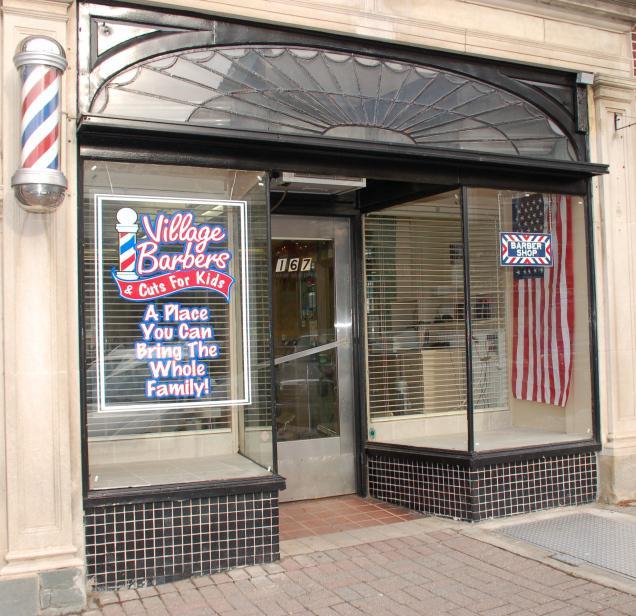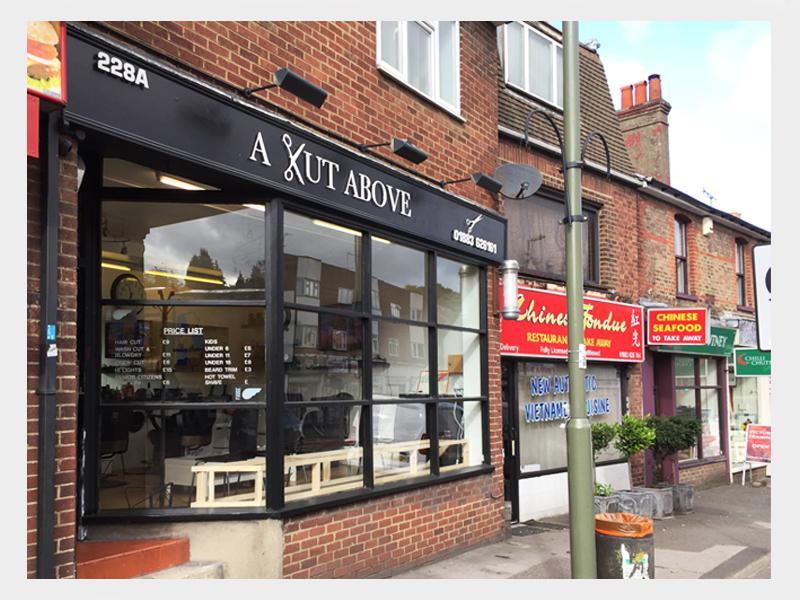The first image is the image on the left, the second image is the image on the right. Analyze the images presented: Is the assertion "A barber shop has a red brick exterior with a row of black-rimmed windows parallel to the sidewalk." valid? Answer yes or no. Yes. 